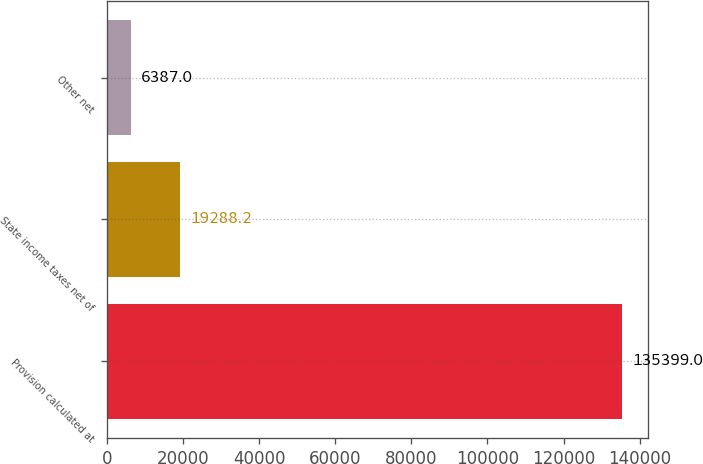Convert chart. <chart><loc_0><loc_0><loc_500><loc_500><bar_chart><fcel>Provision calculated at<fcel>State income taxes net of<fcel>Other net<nl><fcel>135399<fcel>19288.2<fcel>6387<nl></chart> 